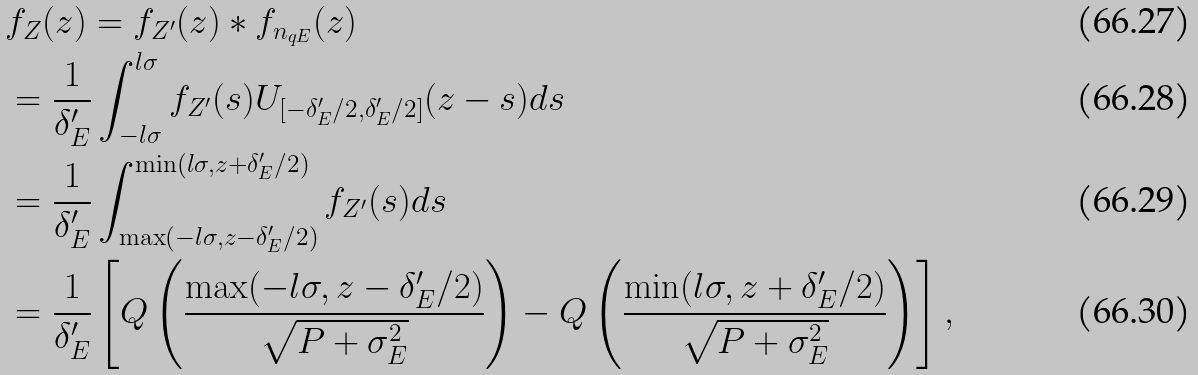<formula> <loc_0><loc_0><loc_500><loc_500>& f _ { Z } ( z ) = f _ { Z ^ { \prime } } ( z ) * f _ { n _ { q E } } ( z ) \\ & = \frac { 1 } { \delta ^ { \prime } _ { E } } \int _ { - l \sigma } ^ { l \sigma } f _ { Z ^ { \prime } } ( s ) U _ { [ - \delta ^ { \prime } _ { E } / 2 , \delta ^ { \prime } _ { E } / 2 ] } ( z - s ) d s \\ & = \frac { 1 } { \delta ^ { \prime } _ { E } } \int _ { \max ( - l \sigma , z - \delta ^ { \prime } _ { E } / 2 ) } ^ { \min ( l \sigma , z + \delta ^ { \prime } _ { E } / 2 ) } f _ { Z ^ { \prime } } ( s ) d s \\ & = \frac { 1 } { \delta ^ { \prime } _ { E } } \left [ Q \left ( \frac { \max ( - l \sigma , z - \delta ^ { \prime } _ { E } / 2 ) } { \sqrt { P + \sigma _ { E } ^ { 2 } } } \right ) - Q \left ( \frac { \min ( l \sigma , z + \delta ^ { \prime } _ { E } / 2 ) } { \sqrt { P + \sigma _ { E } ^ { 2 } } } \right ) \right ] ,</formula> 